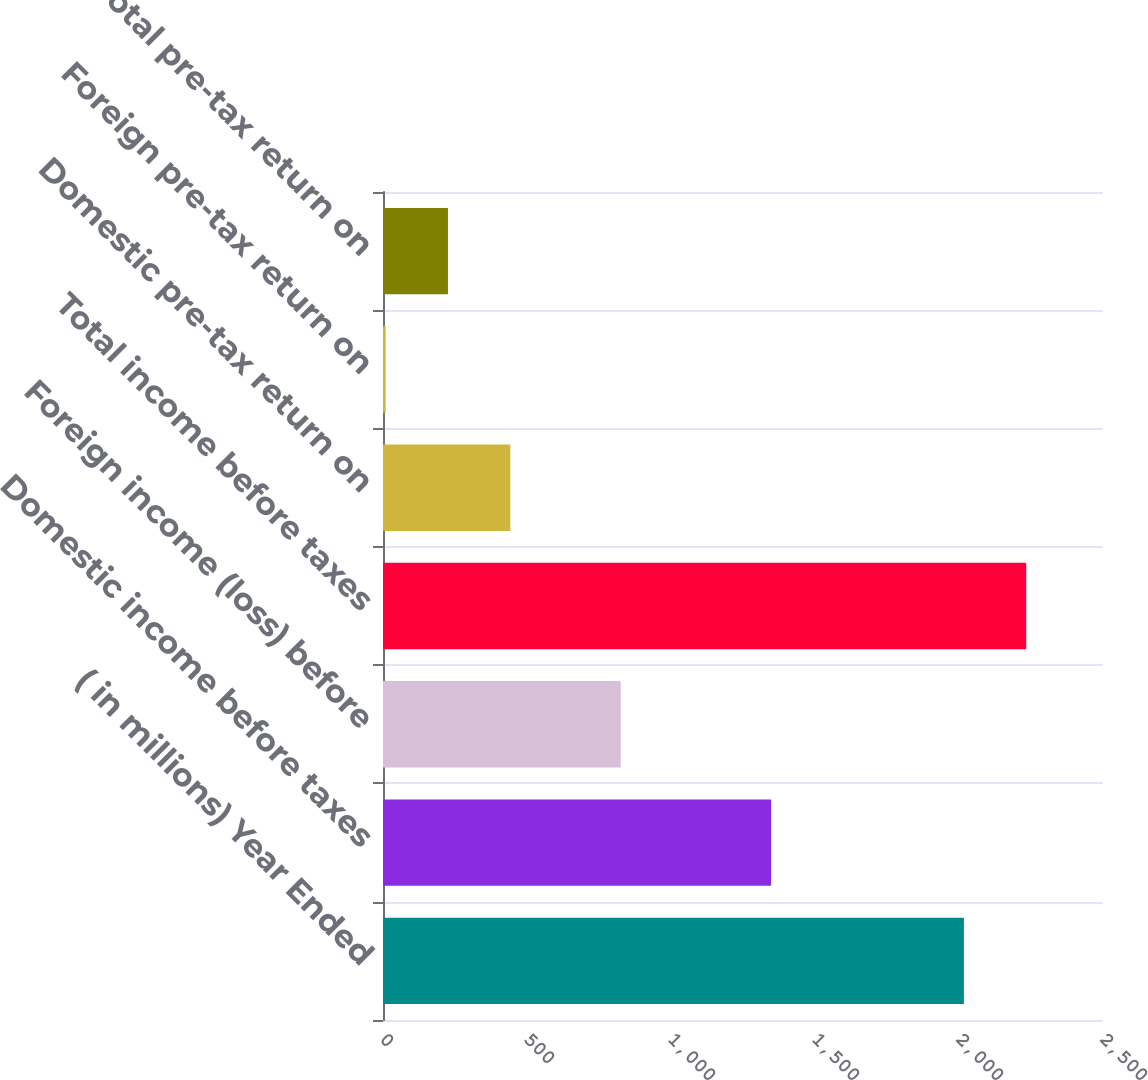<chart> <loc_0><loc_0><loc_500><loc_500><bar_chart><fcel>( in millions) Year Ended<fcel>Domestic income before taxes<fcel>Foreign income (loss) before<fcel>Total income before taxes<fcel>Domestic pre-tax return on<fcel>Foreign pre-tax return on<fcel>Total pre-tax return on<nl><fcel>2017<fcel>1347.8<fcel>825.5<fcel>2233.41<fcel>442.02<fcel>9.2<fcel>225.61<nl></chart> 